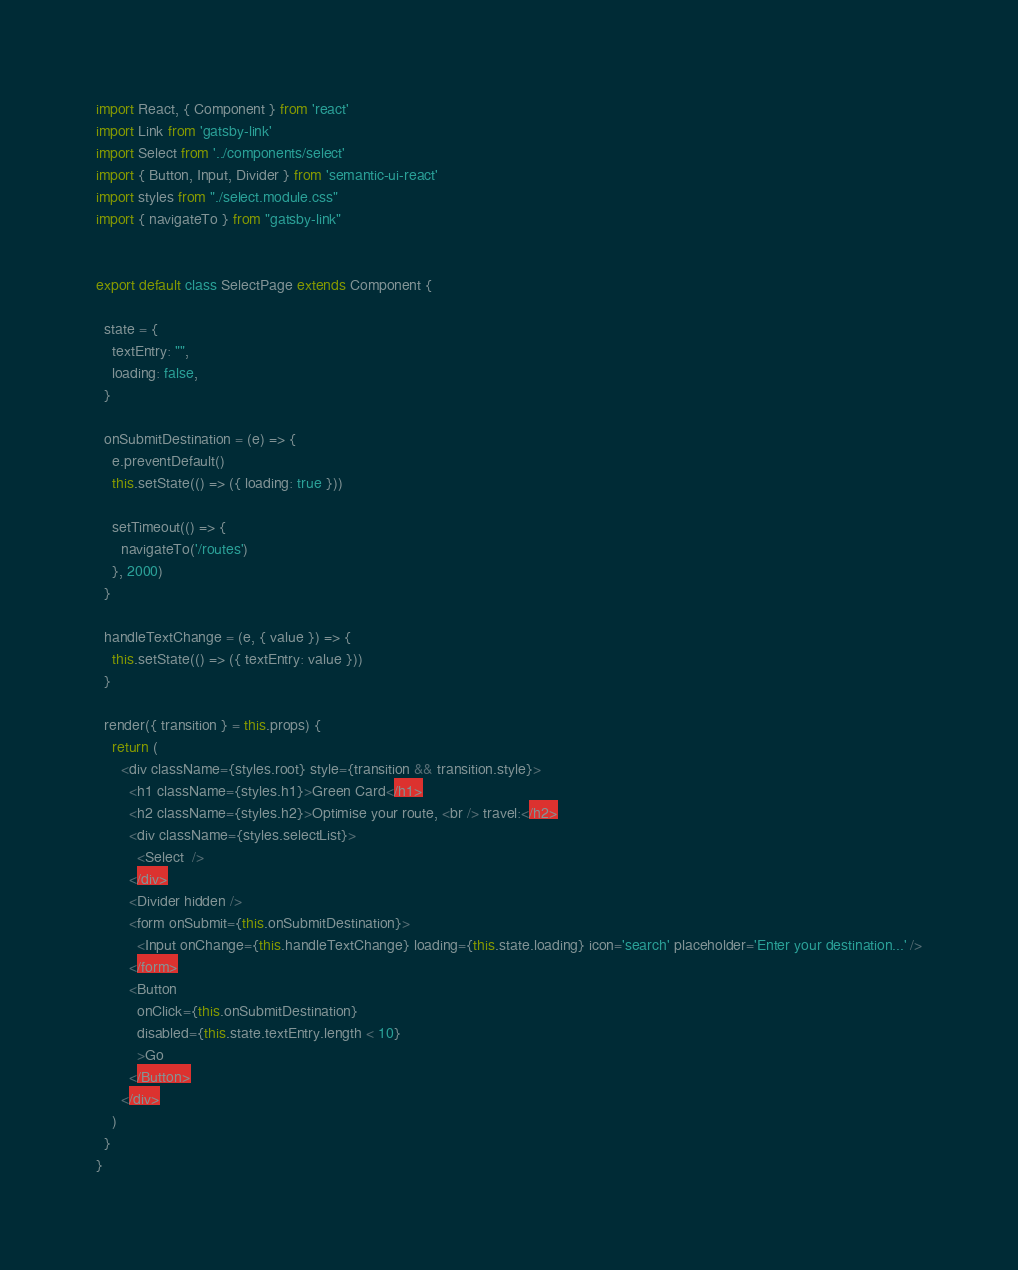Convert code to text. <code><loc_0><loc_0><loc_500><loc_500><_JavaScript_>import React, { Component } from 'react'
import Link from 'gatsby-link'
import Select from '../components/select'
import { Button, Input, Divider } from 'semantic-ui-react'
import styles from "./select.module.css"
import { navigateTo } from "gatsby-link"


export default class SelectPage extends Component {

  state = {
    textEntry: "",
    loading: false,
  }

  onSubmitDestination = (e) => {
    e.preventDefault()
    this.setState(() => ({ loading: true }))

    setTimeout(() => {
      navigateTo('/routes')
    }, 2000)
  }

  handleTextChange = (e, { value }) => {
    this.setState(() => ({ textEntry: value }))
  }

  render({ transition } = this.props) {
    return (
      <div className={styles.root} style={transition && transition.style}>
        <h1 className={styles.h1}>Green Card</h1>
        <h2 className={styles.h2}>Optimise your route, <br /> travel:</h2>
        <div className={styles.selectList}>
          <Select  />
        </div>
        <Divider hidden />
        <form onSubmit={this.onSubmitDestination}>
          <Input onChange={this.handleTextChange} loading={this.state.loading} icon='search' placeholder='Enter your destination...' />
        </form>
        <Button
          onClick={this.onSubmitDestination}
          disabled={this.state.textEntry.length < 10}
          >Go
        </Button>
      </div>
    )
  }
}
</code> 